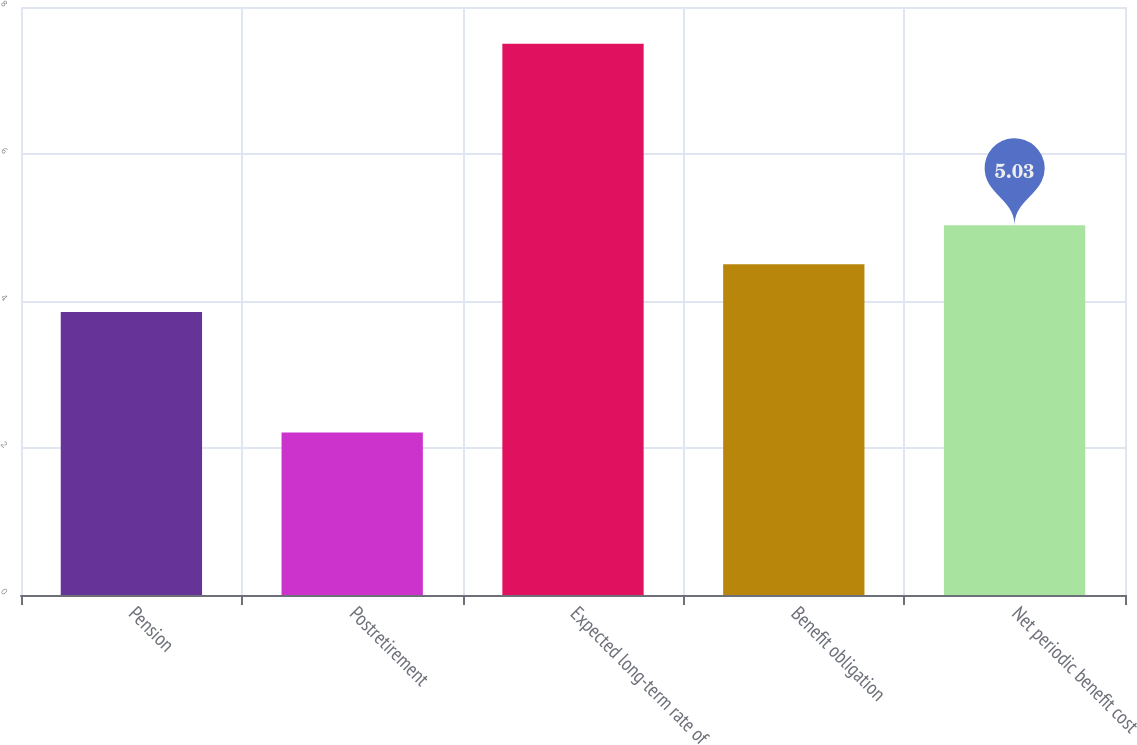<chart> <loc_0><loc_0><loc_500><loc_500><bar_chart><fcel>Pension<fcel>Postretirement<fcel>Expected long-term rate of<fcel>Benefit obligation<fcel>Net periodic benefit cost<nl><fcel>3.85<fcel>2.21<fcel>7.5<fcel>4.5<fcel>5.03<nl></chart> 